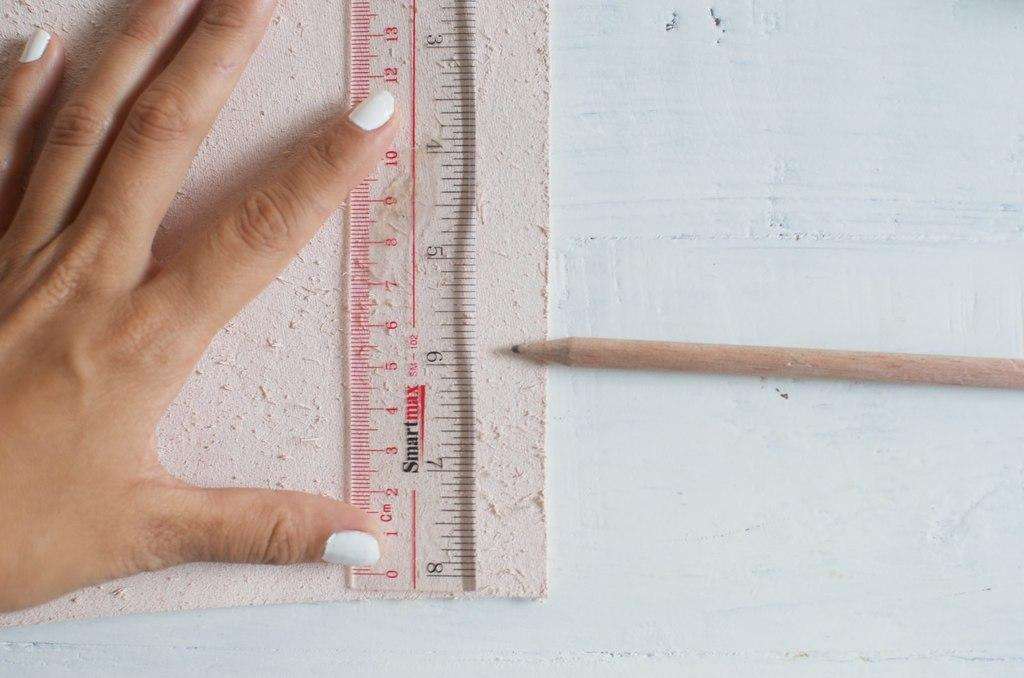<image>
Summarize the visual content of the image. A person using a Smartmax brand ruler and a pencil to draw a line. 